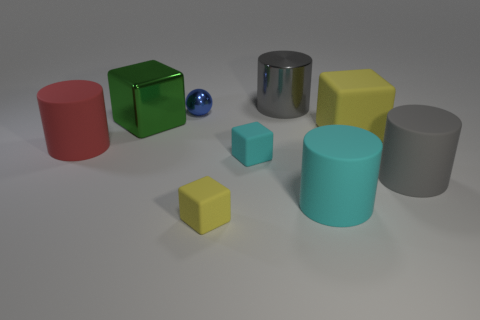The metallic block is what color?
Provide a short and direct response. Green. How many other things are there of the same size as the green metal block?
Offer a terse response. 5. What is the material of the cyan object that is the same shape as the gray matte object?
Offer a very short reply. Rubber. What is the material of the gray object on the left side of the yellow block that is behind the red cylinder on the left side of the large cyan object?
Your response must be concise. Metal. There is a cyan cube that is made of the same material as the red cylinder; what is its size?
Give a very brief answer. Small. Is there anything else that is the same color as the metallic cylinder?
Keep it short and to the point. Yes. There is a large cylinder right of the big yellow matte object; is it the same color as the cylinder that is behind the big rubber block?
Your answer should be compact. Yes. There is a large cylinder behind the blue metallic ball; what is its color?
Provide a short and direct response. Gray. Does the yellow cube in front of the cyan matte cylinder have the same size as the tiny shiny thing?
Offer a very short reply. Yes. Are there fewer tiny rubber cubes than yellow metal cylinders?
Keep it short and to the point. No. 